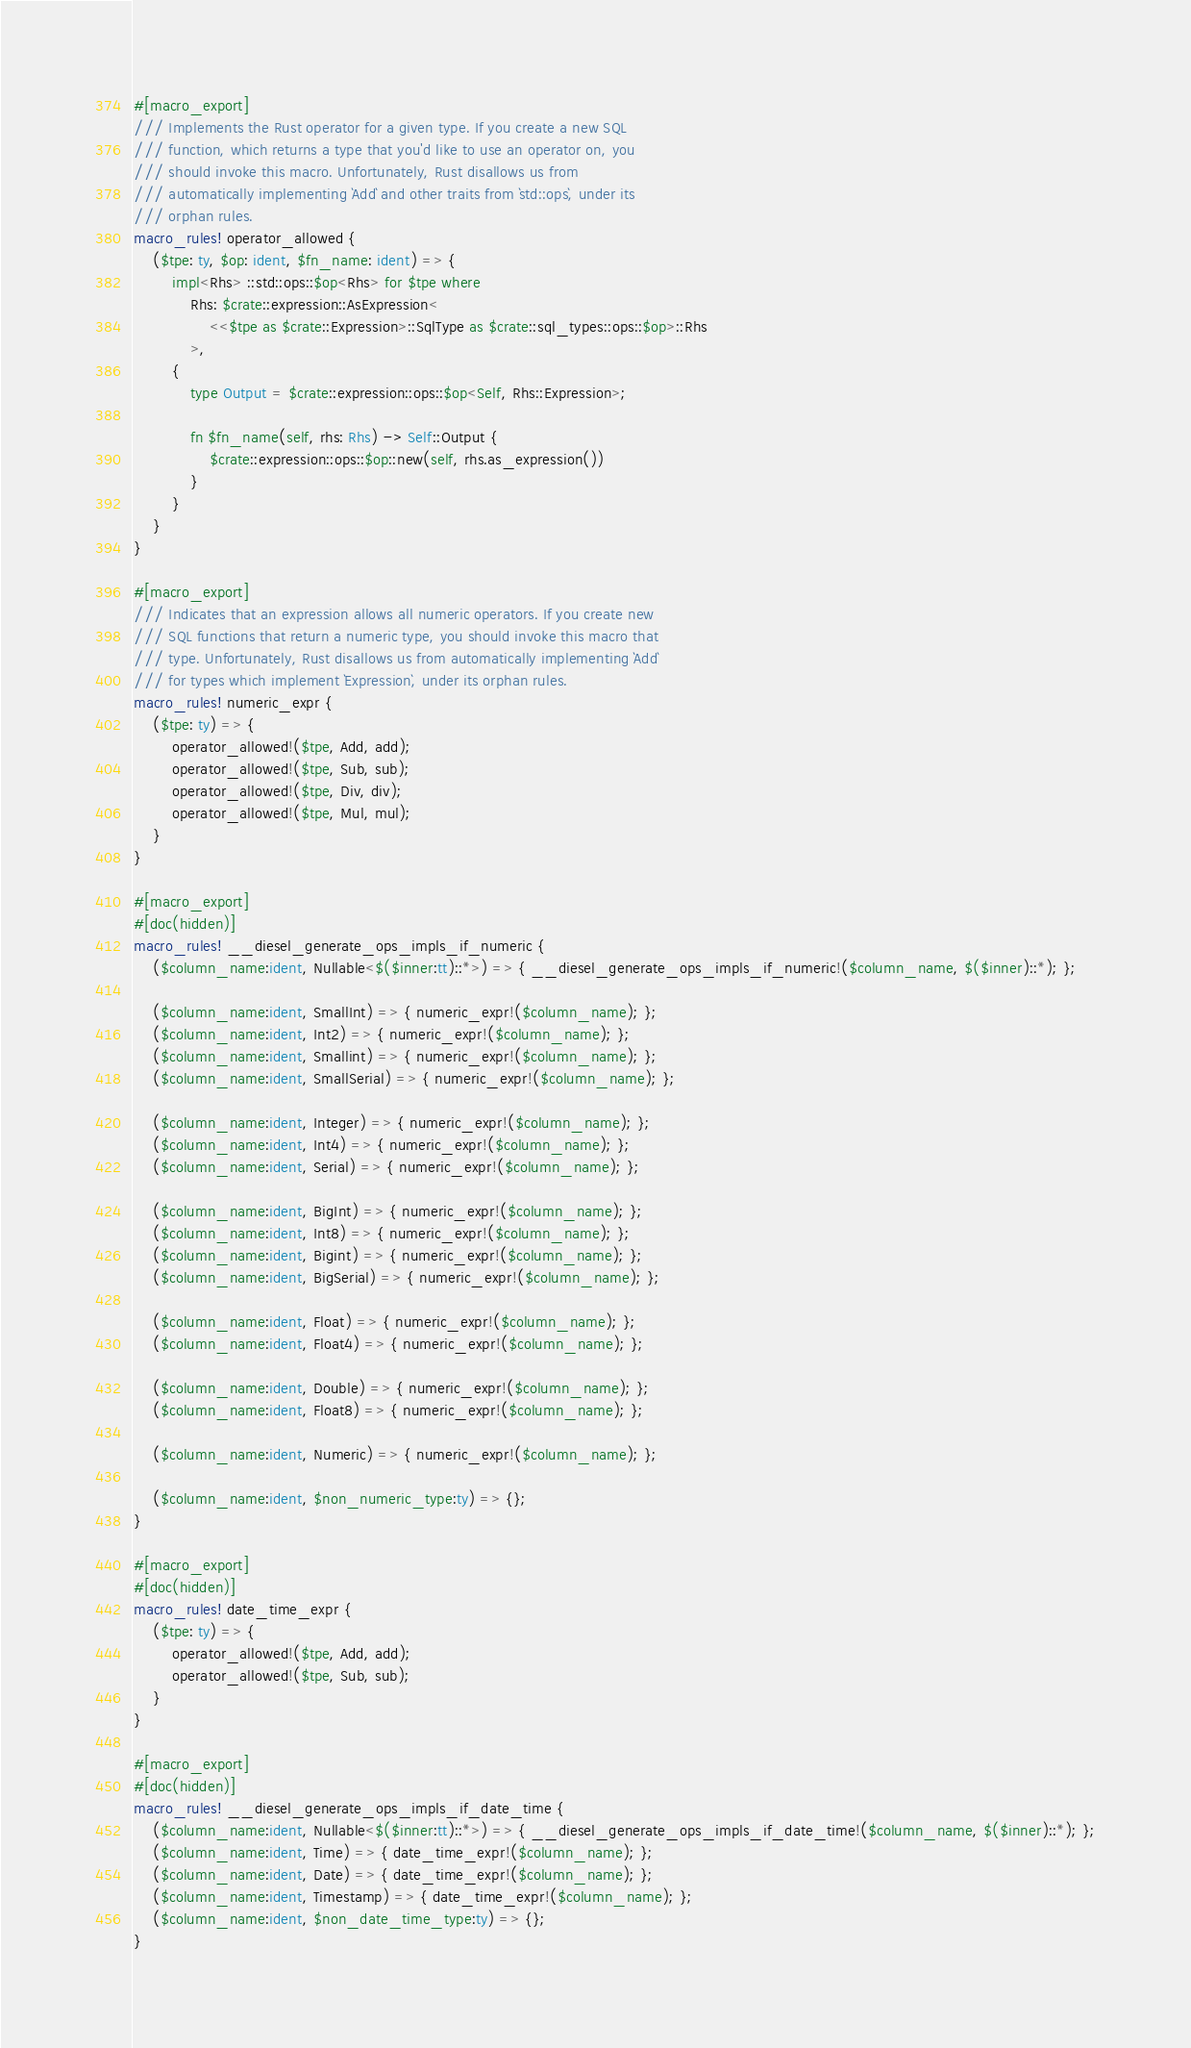<code> <loc_0><loc_0><loc_500><loc_500><_Rust_>#[macro_export]
/// Implements the Rust operator for a given type. If you create a new SQL
/// function, which returns a type that you'd like to use an operator on, you
/// should invoke this macro. Unfortunately, Rust disallows us from
/// automatically implementing `Add` and other traits from `std::ops`, under its
/// orphan rules.
macro_rules! operator_allowed {
    ($tpe: ty, $op: ident, $fn_name: ident) => {
        impl<Rhs> ::std::ops::$op<Rhs> for $tpe where
            Rhs: $crate::expression::AsExpression<
                <<$tpe as $crate::Expression>::SqlType as $crate::sql_types::ops::$op>::Rhs
            >,
        {
            type Output = $crate::expression::ops::$op<Self, Rhs::Expression>;

            fn $fn_name(self, rhs: Rhs) -> Self::Output {
                $crate::expression::ops::$op::new(self, rhs.as_expression())
            }
        }
    }
}

#[macro_export]
/// Indicates that an expression allows all numeric operators. If you create new
/// SQL functions that return a numeric type, you should invoke this macro that
/// type. Unfortunately, Rust disallows us from automatically implementing `Add`
/// for types which implement `Expression`, under its orphan rules.
macro_rules! numeric_expr {
    ($tpe: ty) => {
        operator_allowed!($tpe, Add, add);
        operator_allowed!($tpe, Sub, sub);
        operator_allowed!($tpe, Div, div);
        operator_allowed!($tpe, Mul, mul);
    }
}

#[macro_export]
#[doc(hidden)]
macro_rules! __diesel_generate_ops_impls_if_numeric {
    ($column_name:ident, Nullable<$($inner:tt)::*>) => { __diesel_generate_ops_impls_if_numeric!($column_name, $($inner)::*); };

    ($column_name:ident, SmallInt) => { numeric_expr!($column_name); };
    ($column_name:ident, Int2) => { numeric_expr!($column_name); };
    ($column_name:ident, Smallint) => { numeric_expr!($column_name); };
    ($column_name:ident, SmallSerial) => { numeric_expr!($column_name); };

    ($column_name:ident, Integer) => { numeric_expr!($column_name); };
    ($column_name:ident, Int4) => { numeric_expr!($column_name); };
    ($column_name:ident, Serial) => { numeric_expr!($column_name); };

    ($column_name:ident, BigInt) => { numeric_expr!($column_name); };
    ($column_name:ident, Int8) => { numeric_expr!($column_name); };
    ($column_name:ident, Bigint) => { numeric_expr!($column_name); };
    ($column_name:ident, BigSerial) => { numeric_expr!($column_name); };

    ($column_name:ident, Float) => { numeric_expr!($column_name); };
    ($column_name:ident, Float4) => { numeric_expr!($column_name); };

    ($column_name:ident, Double) => { numeric_expr!($column_name); };
    ($column_name:ident, Float8) => { numeric_expr!($column_name); };

    ($column_name:ident, Numeric) => { numeric_expr!($column_name); };

    ($column_name:ident, $non_numeric_type:ty) => {};
}

#[macro_export]
#[doc(hidden)]
macro_rules! date_time_expr {
    ($tpe: ty) => {
        operator_allowed!($tpe, Add, add);
        operator_allowed!($tpe, Sub, sub);
    }
}

#[macro_export]
#[doc(hidden)]
macro_rules! __diesel_generate_ops_impls_if_date_time {
    ($column_name:ident, Nullable<$($inner:tt)::*>) => { __diesel_generate_ops_impls_if_date_time!($column_name, $($inner)::*); };
    ($column_name:ident, Time) => { date_time_expr!($column_name); };
    ($column_name:ident, Date) => { date_time_expr!($column_name); };
    ($column_name:ident, Timestamp) => { date_time_expr!($column_name); };
    ($column_name:ident, $non_date_time_type:ty) => {};
}
</code> 